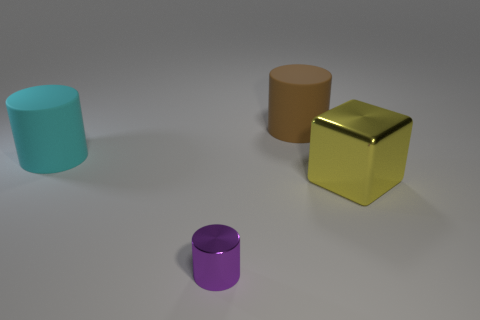Is there anything else that has the same size as the purple thing?
Offer a very short reply. No. How big is the matte cylinder behind the cyan cylinder in front of the matte object to the right of the small metal cylinder?
Provide a succinct answer. Large. How many large cyan objects are made of the same material as the purple object?
Provide a succinct answer. 0. Is the number of big blocks less than the number of red metallic things?
Give a very brief answer. No. What is the size of the other matte object that is the same shape as the big cyan object?
Provide a short and direct response. Large. Is the object in front of the large yellow thing made of the same material as the large yellow block?
Offer a terse response. Yes. Does the big brown thing have the same shape as the big cyan matte thing?
Ensure brevity in your answer.  Yes. How many things are large objects that are right of the tiny shiny thing or large brown rubber cylinders?
Make the answer very short. 2. There is a purple thing that is made of the same material as the big yellow thing; what size is it?
Make the answer very short. Small. How many big cylinders are the same color as the large cube?
Provide a short and direct response. 0. 